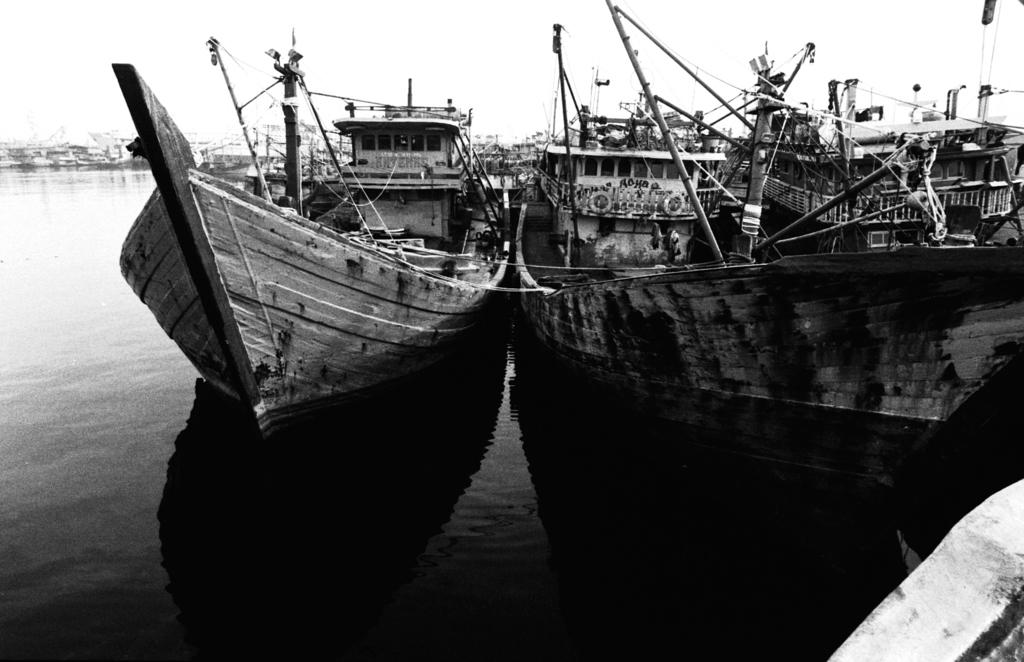What is the color scheme of the image? The image is black and white. What can be seen in the water in the image? There are boats in the water. What is visible in the background of the image? The sky is visible in the background of the image. What type of ray is swimming in the water in the image? There are no rays present in the image; it features boats in the water. Where is the sink located in the image? There is no sink present in the image. 